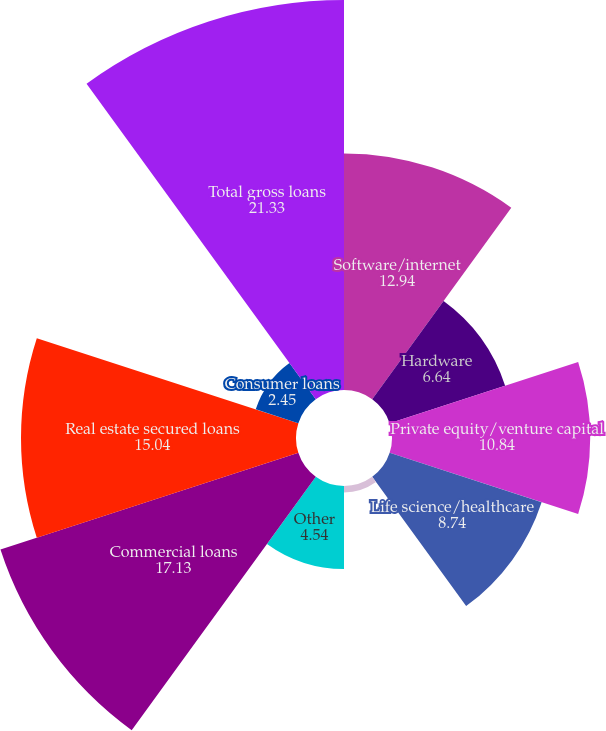<chart> <loc_0><loc_0><loc_500><loc_500><pie_chart><fcel>Software/internet<fcel>Hardware<fcel>Private equity/venture capital<fcel>Life science/healthcare<fcel>Premium wine<fcel>Other<fcel>Commercial loans<fcel>Real estate secured loans<fcel>Consumer loans<fcel>Total gross loans<nl><fcel>12.94%<fcel>6.64%<fcel>10.84%<fcel>8.74%<fcel>0.35%<fcel>4.54%<fcel>17.13%<fcel>15.04%<fcel>2.45%<fcel>21.33%<nl></chart> 